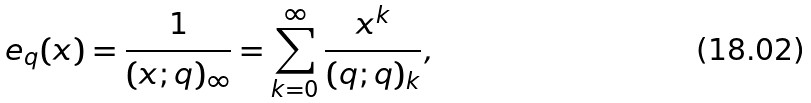Convert formula to latex. <formula><loc_0><loc_0><loc_500><loc_500>e _ { q } ( x ) = \frac { 1 } { ( x ; q ) _ { \infty } } = \sum _ { k = 0 } ^ { \infty } \frac { x ^ { k } } { ( q ; q ) _ { k } } ,</formula> 